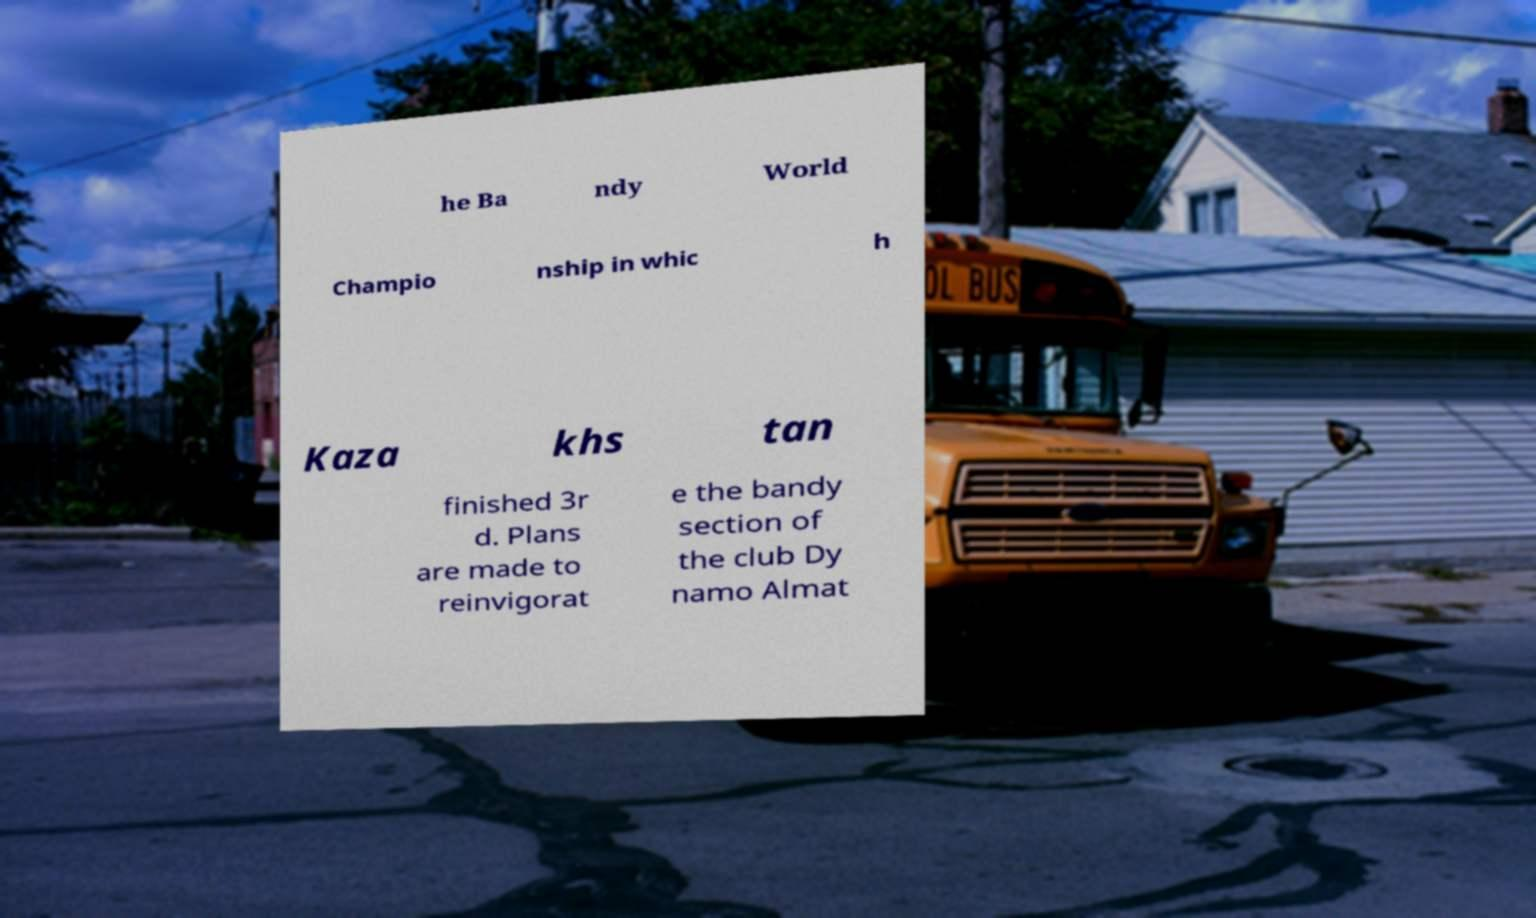I need the written content from this picture converted into text. Can you do that? he Ba ndy World Champio nship in whic h Kaza khs tan finished 3r d. Plans are made to reinvigorat e the bandy section of the club Dy namo Almat 